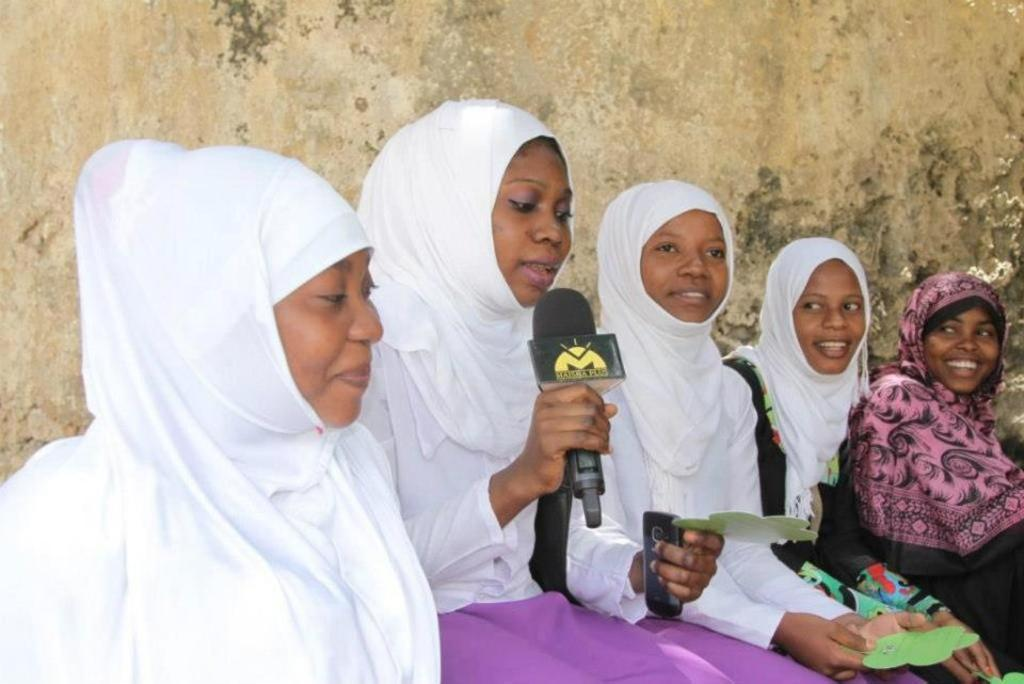What is the general activity of the people in the image? The people in the image are sitting and holding papers. Can you describe the woman in the group? The woman in the group is holding a mic and a cellphone. What is visible in the background of the image? There is a wall visible in the background of the image. What type of muscle is being flexed by the people in the image? There is no indication of any muscle flexing in the image; the people are sitting and holding papers. Is there a sink visible in the image? No, there is no sink present in the image; only a wall is visible in the background. 